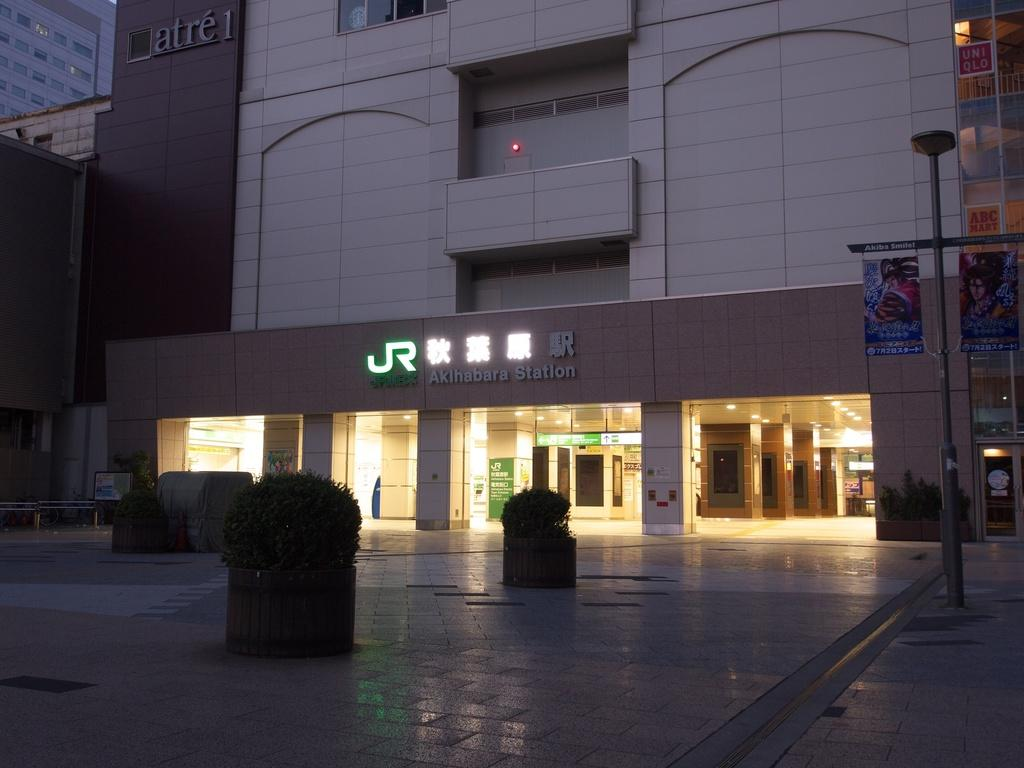What type of flooring is visible in the image? There is a marble floor in the image. What structures can be seen in the image? There are buildings in the image. What type of vegetation is present in front of the buildings? There are bushes in front of the buildings. What is the daughter discussing with her friends in the image? There is no daughter or friends present in the image. 